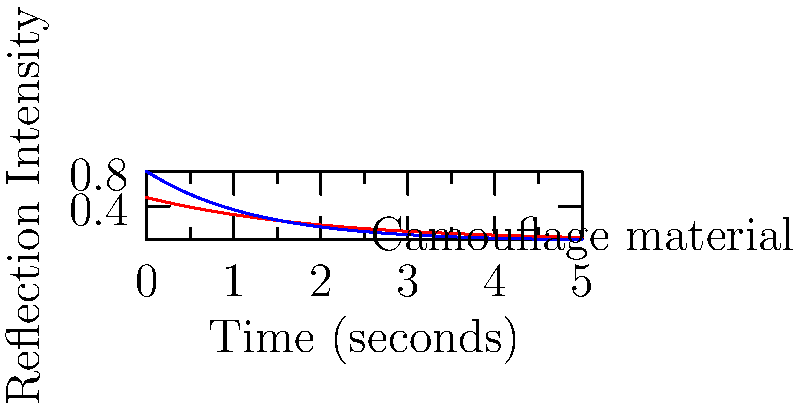In developing advanced camouflage for military uniforms, you encounter the reflection patterns shown in the graph. The red line represents visible light reflection, while the blue line represents infrared reflection. How does this pattern contribute to effective camouflage in both day and night conditions? To understand how this reflection pattern contributes to effective camouflage:

1. Visible light reflection (red line):
   - Starts high but rapidly decreases over time
   - This indicates that the material quickly absorbs most visible light
   - Result: Low visibility in daylight conditions

2. Infrared reflection (blue line):
   - Also decreases over time, but at a slower rate than visible light
   - The material reflects some infrared radiation, but not excessively
   - Result: Reduced detectability by night vision equipment

3. Comparison of the two curves:
   - Visible light reflection decreases faster than infrared
   - This difference helps balance day and night camouflage effectiveness

4. Overall pattern:
   - Both reflections decrease over time, indicating good absorption properties
   - The material doesn't maintain high reflectivity in either spectrum

5. Military application:
   - Daytime: Low visible light reflection helps blend with surroundings
   - Nighttime: Moderate infrared reflection prevents appearing as a "cold spot" in thermal imaging

This reflection pattern allows the uniform to provide effective camouflage in both day and night conditions by balancing visible light absorption for daytime concealment and controlled infrared reflection for nighttime evasion of detection.
Answer: Rapid visible light absorption for daytime concealment; controlled infrared reflection for nighttime thermal signature management. 